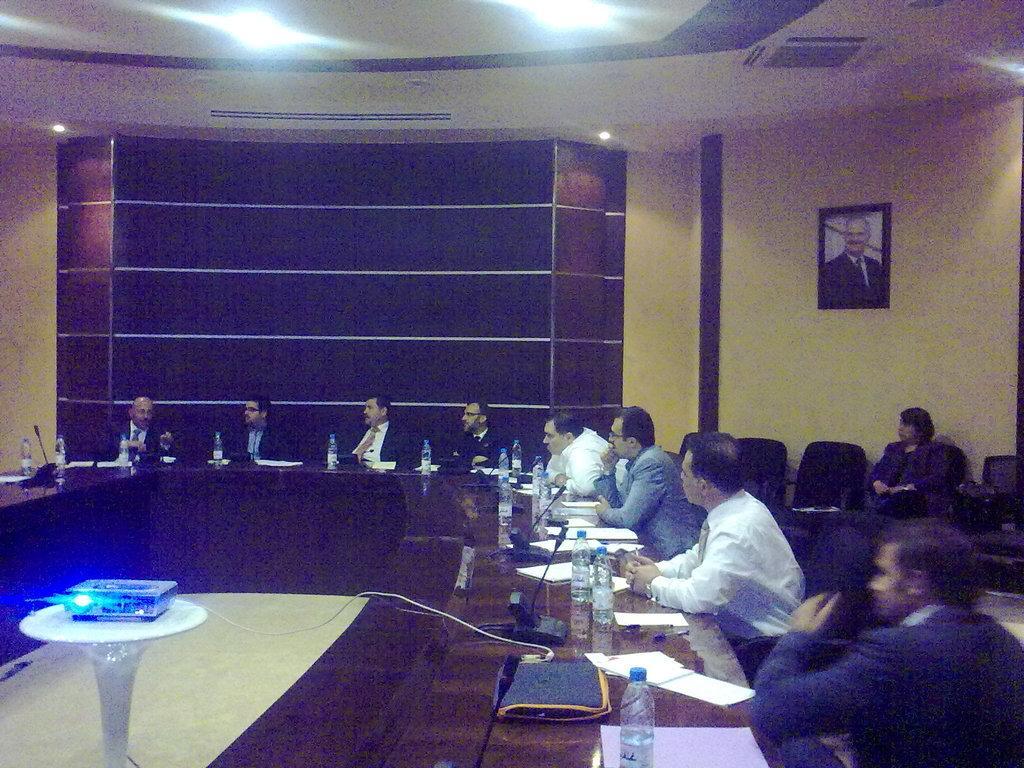Could you give a brief overview of what you see in this image? A group of men are sitting at a table and discussing among themselves. 